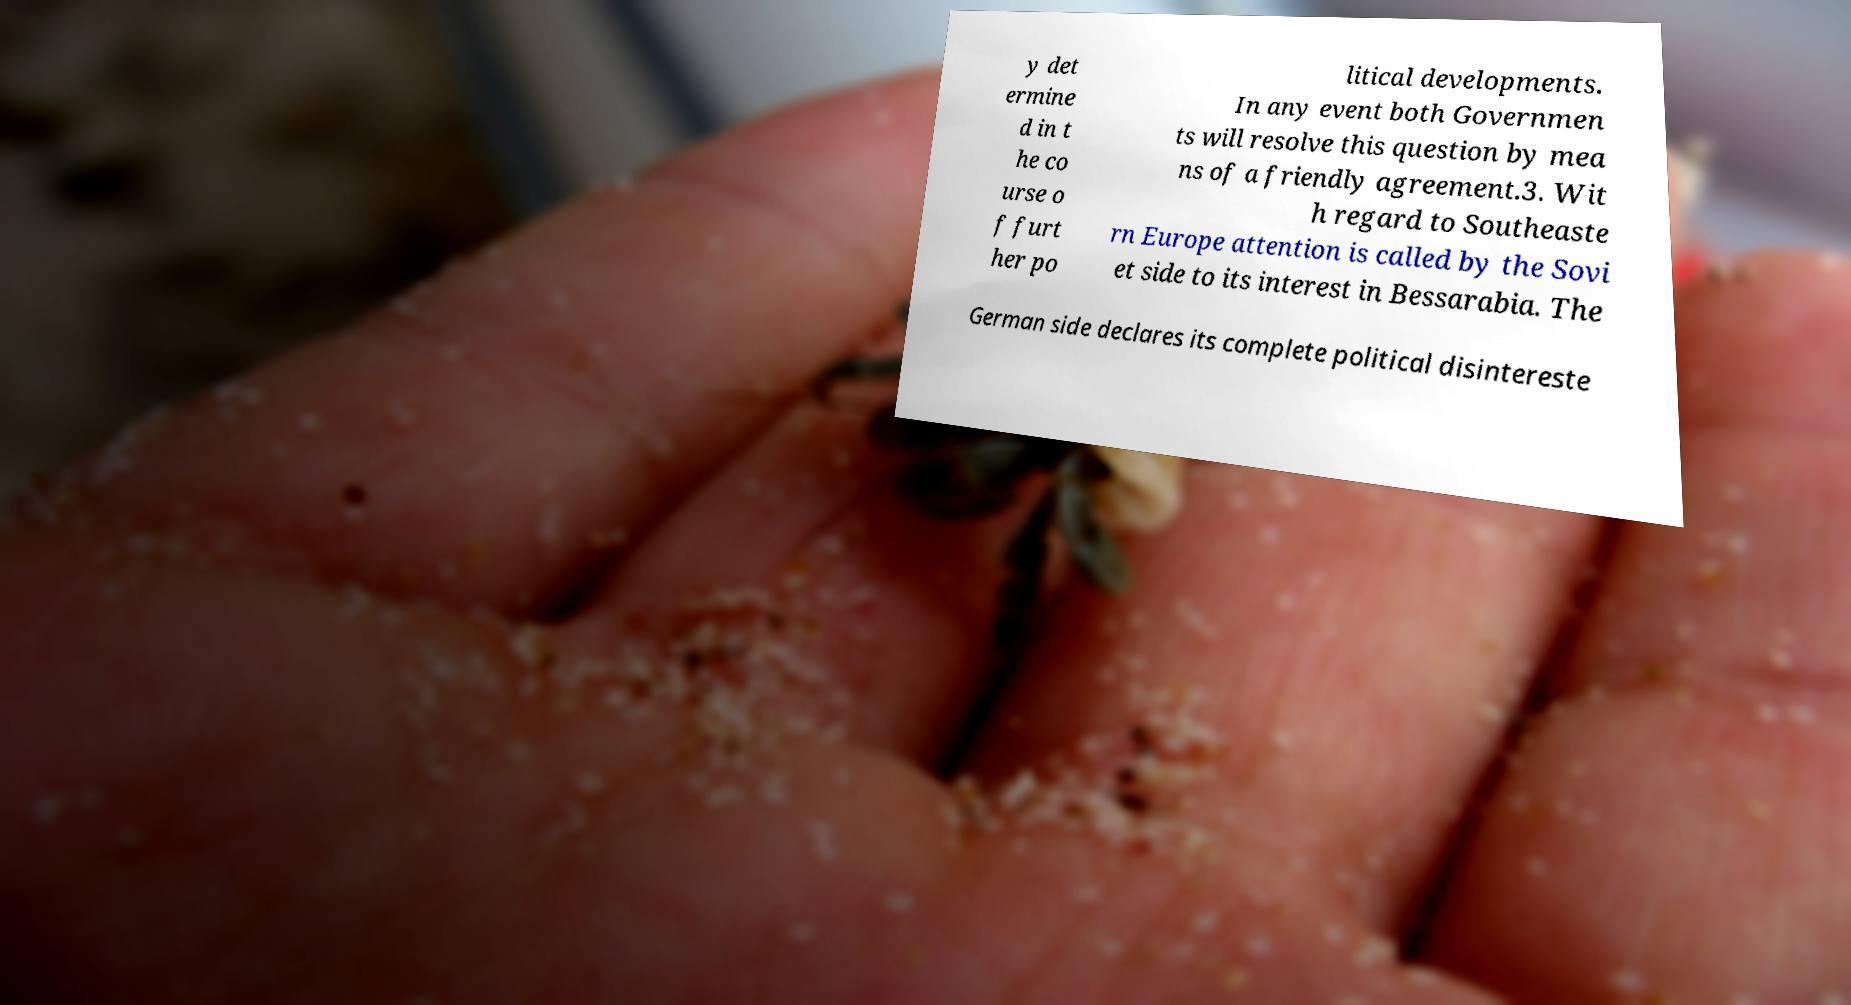Please read and relay the text visible in this image. What does it say? y det ermine d in t he co urse o f furt her po litical developments. In any event both Governmen ts will resolve this question by mea ns of a friendly agreement.3. Wit h regard to Southeaste rn Europe attention is called by the Sovi et side to its interest in Bessarabia. The German side declares its complete political disintereste 